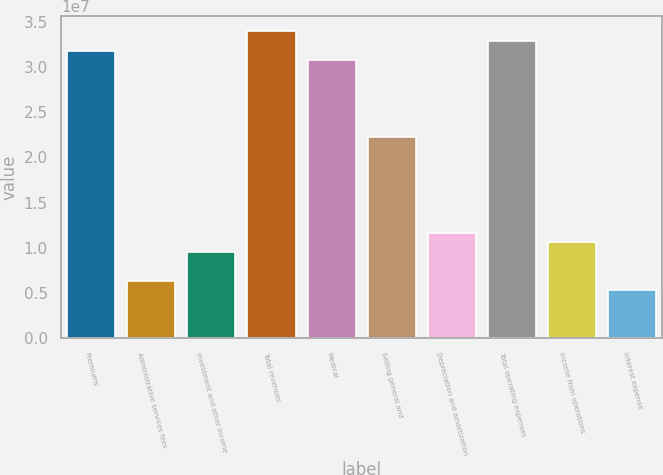Convert chart to OTSL. <chart><loc_0><loc_0><loc_500><loc_500><bar_chart><fcel>Premiums<fcel>Administrative services fees<fcel>Investment and other income<fcel>Total revenues<fcel>Medical<fcel>Selling general and<fcel>Depreciation and amortization<fcel>Total operating expenses<fcel>Income from operations<fcel>Interest expense<nl><fcel>3.17878e+07<fcel>6.35757e+06<fcel>9.53636e+06<fcel>3.3907e+07<fcel>3.07283e+07<fcel>2.22515e+07<fcel>1.16555e+07<fcel>3.28474e+07<fcel>1.0596e+07<fcel>5.29798e+06<nl></chart> 